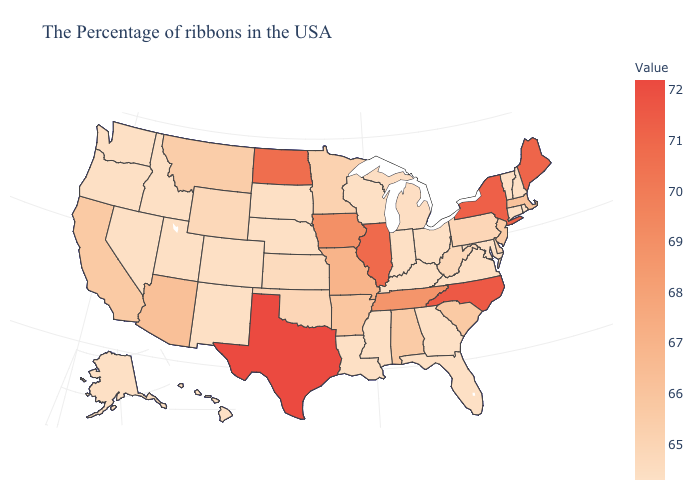Among the states that border Ohio , which have the highest value?
Keep it brief. Pennsylvania. Does South Carolina have the highest value in the USA?
Give a very brief answer. No. Among the states that border Arizona , does California have the highest value?
Answer briefly. Yes. Does Connecticut have a lower value than Minnesota?
Answer briefly. Yes. Does the map have missing data?
Answer briefly. No. Among the states that border Texas , does Louisiana have the lowest value?
Keep it brief. Yes. Is the legend a continuous bar?
Write a very short answer. Yes. 